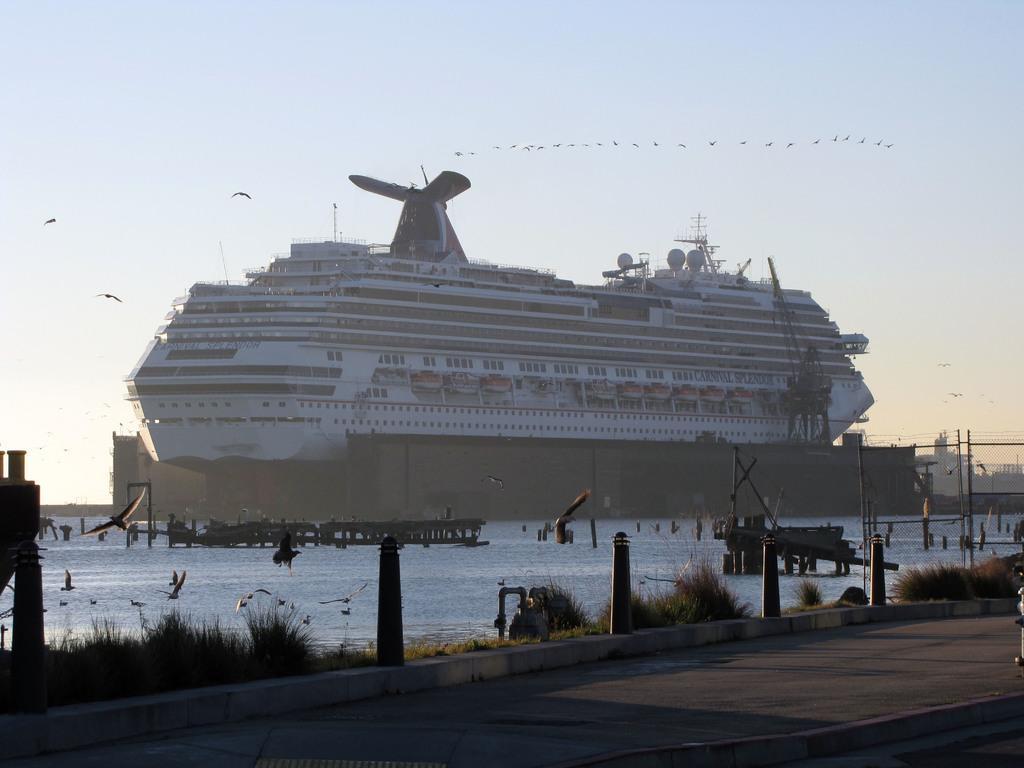Can you describe this image briefly? In this picture we can see big cargo ship on the water. On the top of the ship we can see tower and other panels. At the bottom road, beside that we can see grass and fencing. At the top we can see birds and sky. On the left there is steel gate and other boats. 